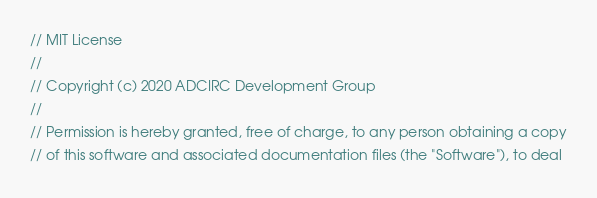<code> <loc_0><loc_0><loc_500><loc_500><_C_>// MIT License
//
// Copyright (c) 2020 ADCIRC Development Group
//
// Permission is hereby granted, free of charge, to any person obtaining a copy
// of this software and associated documentation files (the "Software"), to deal</code> 